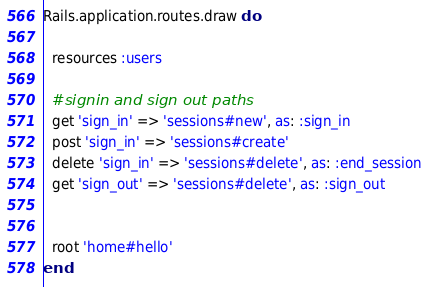<code> <loc_0><loc_0><loc_500><loc_500><_Ruby_>Rails.application.routes.draw do

  resources :users
  
  #signin and sign out paths
  get 'sign_in' => 'sessions#new', as: :sign_in
  post 'sign_in' => 'sessions#create'
  delete 'sign_in' => 'sessions#delete', as: :end_session
  get 'sign_out' => 'sessions#delete', as: :sign_out
   

  root 'home#hello'
end
</code> 